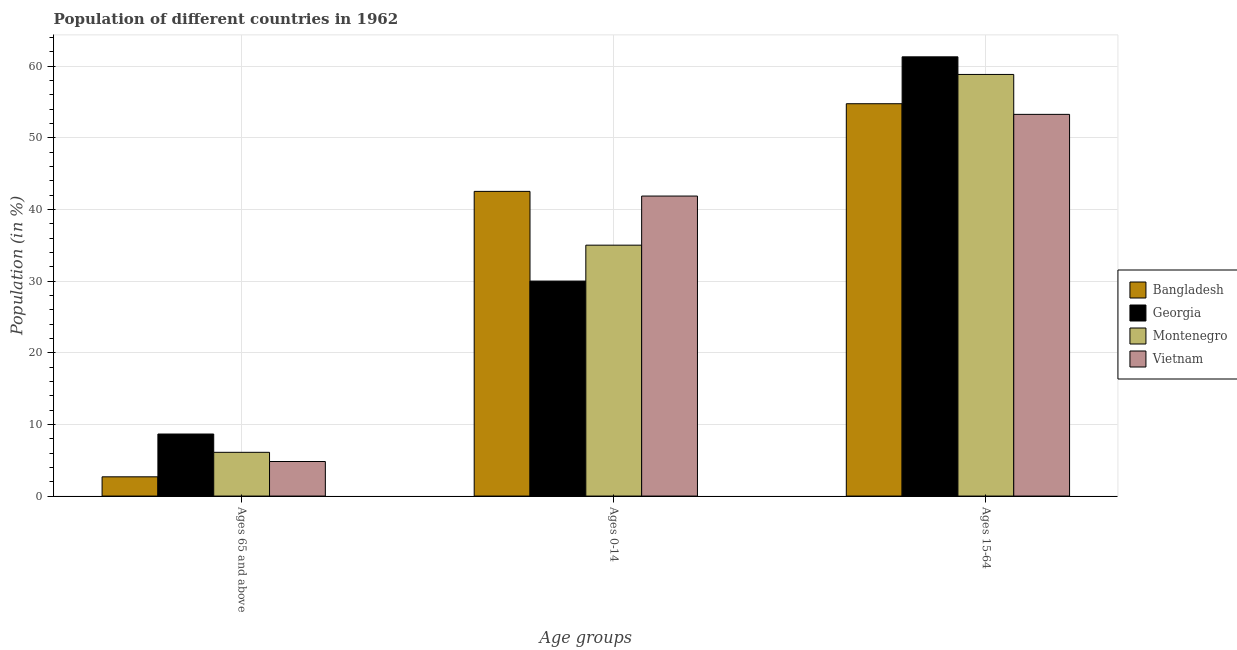How many groups of bars are there?
Give a very brief answer. 3. Are the number of bars per tick equal to the number of legend labels?
Your response must be concise. Yes. How many bars are there on the 2nd tick from the left?
Ensure brevity in your answer.  4. What is the label of the 1st group of bars from the left?
Your answer should be compact. Ages 65 and above. What is the percentage of population within the age-group 0-14 in Vietnam?
Provide a succinct answer. 41.88. Across all countries, what is the maximum percentage of population within the age-group 15-64?
Give a very brief answer. 61.32. Across all countries, what is the minimum percentage of population within the age-group 15-64?
Keep it short and to the point. 53.29. In which country was the percentage of population within the age-group 15-64 maximum?
Make the answer very short. Georgia. In which country was the percentage of population within the age-group 0-14 minimum?
Your answer should be compact. Georgia. What is the total percentage of population within the age-group 0-14 in the graph?
Give a very brief answer. 149.47. What is the difference between the percentage of population within the age-group 0-14 in Georgia and that in Montenegro?
Ensure brevity in your answer.  -5.01. What is the difference between the percentage of population within the age-group 15-64 in Montenegro and the percentage of population within the age-group 0-14 in Bangladesh?
Provide a succinct answer. 16.33. What is the average percentage of population within the age-group of 65 and above per country?
Make the answer very short. 5.57. What is the difference between the percentage of population within the age-group 0-14 and percentage of population within the age-group of 65 and above in Montenegro?
Keep it short and to the point. 28.92. What is the ratio of the percentage of population within the age-group 15-64 in Vietnam to that in Montenegro?
Make the answer very short. 0.91. Is the difference between the percentage of population within the age-group 15-64 in Georgia and Montenegro greater than the difference between the percentage of population within the age-group 0-14 in Georgia and Montenegro?
Your answer should be very brief. Yes. What is the difference between the highest and the second highest percentage of population within the age-group 15-64?
Your answer should be very brief. 2.46. What is the difference between the highest and the lowest percentage of population within the age-group 0-14?
Offer a very short reply. 12.52. Is the sum of the percentage of population within the age-group 0-14 in Montenegro and Georgia greater than the maximum percentage of population within the age-group 15-64 across all countries?
Keep it short and to the point. Yes. What does the 2nd bar from the left in Ages 65 and above represents?
Make the answer very short. Georgia. What does the 2nd bar from the right in Ages 65 and above represents?
Keep it short and to the point. Montenegro. Is it the case that in every country, the sum of the percentage of population within the age-group of 65 and above and percentage of population within the age-group 0-14 is greater than the percentage of population within the age-group 15-64?
Make the answer very short. No. Are all the bars in the graph horizontal?
Offer a terse response. No. How many countries are there in the graph?
Your answer should be very brief. 4. What is the difference between two consecutive major ticks on the Y-axis?
Make the answer very short. 10. Does the graph contain any zero values?
Offer a very short reply. No. Does the graph contain grids?
Keep it short and to the point. Yes. How are the legend labels stacked?
Ensure brevity in your answer.  Vertical. What is the title of the graph?
Give a very brief answer. Population of different countries in 1962. Does "Central African Republic" appear as one of the legend labels in the graph?
Ensure brevity in your answer.  No. What is the label or title of the X-axis?
Offer a terse response. Age groups. What is the Population (in %) of Bangladesh in Ages 65 and above?
Make the answer very short. 2.69. What is the Population (in %) in Georgia in Ages 65 and above?
Ensure brevity in your answer.  8.66. What is the Population (in %) in Montenegro in Ages 65 and above?
Ensure brevity in your answer.  6.11. What is the Population (in %) in Vietnam in Ages 65 and above?
Provide a succinct answer. 4.82. What is the Population (in %) in Bangladesh in Ages 0-14?
Keep it short and to the point. 42.54. What is the Population (in %) of Georgia in Ages 0-14?
Your answer should be compact. 30.02. What is the Population (in %) in Montenegro in Ages 0-14?
Your response must be concise. 35.03. What is the Population (in %) of Vietnam in Ages 0-14?
Your answer should be very brief. 41.88. What is the Population (in %) of Bangladesh in Ages 15-64?
Ensure brevity in your answer.  54.78. What is the Population (in %) in Georgia in Ages 15-64?
Your response must be concise. 61.32. What is the Population (in %) of Montenegro in Ages 15-64?
Offer a terse response. 58.86. What is the Population (in %) in Vietnam in Ages 15-64?
Make the answer very short. 53.29. Across all Age groups, what is the maximum Population (in %) in Bangladesh?
Give a very brief answer. 54.78. Across all Age groups, what is the maximum Population (in %) in Georgia?
Provide a succinct answer. 61.32. Across all Age groups, what is the maximum Population (in %) in Montenegro?
Give a very brief answer. 58.86. Across all Age groups, what is the maximum Population (in %) of Vietnam?
Your response must be concise. 53.29. Across all Age groups, what is the minimum Population (in %) in Bangladesh?
Provide a succinct answer. 2.69. Across all Age groups, what is the minimum Population (in %) in Georgia?
Provide a short and direct response. 8.66. Across all Age groups, what is the minimum Population (in %) of Montenegro?
Keep it short and to the point. 6.11. Across all Age groups, what is the minimum Population (in %) of Vietnam?
Your answer should be very brief. 4.82. What is the total Population (in %) in Bangladesh in the graph?
Provide a succinct answer. 100. What is the total Population (in %) in Georgia in the graph?
Ensure brevity in your answer.  100. What is the total Population (in %) in Vietnam in the graph?
Give a very brief answer. 100. What is the difference between the Population (in %) of Bangladesh in Ages 65 and above and that in Ages 0-14?
Give a very brief answer. -39.85. What is the difference between the Population (in %) in Georgia in Ages 65 and above and that in Ages 0-14?
Provide a succinct answer. -21.35. What is the difference between the Population (in %) of Montenegro in Ages 65 and above and that in Ages 0-14?
Offer a very short reply. -28.92. What is the difference between the Population (in %) of Vietnam in Ages 65 and above and that in Ages 0-14?
Provide a short and direct response. -37.06. What is the difference between the Population (in %) in Bangladesh in Ages 65 and above and that in Ages 15-64?
Offer a terse response. -52.09. What is the difference between the Population (in %) of Georgia in Ages 65 and above and that in Ages 15-64?
Provide a succinct answer. -52.66. What is the difference between the Population (in %) of Montenegro in Ages 65 and above and that in Ages 15-64?
Provide a succinct answer. -52.75. What is the difference between the Population (in %) in Vietnam in Ages 65 and above and that in Ages 15-64?
Keep it short and to the point. -48.47. What is the difference between the Population (in %) in Bangladesh in Ages 0-14 and that in Ages 15-64?
Offer a terse response. -12.24. What is the difference between the Population (in %) of Georgia in Ages 0-14 and that in Ages 15-64?
Your answer should be compact. -31.31. What is the difference between the Population (in %) in Montenegro in Ages 0-14 and that in Ages 15-64?
Your response must be concise. -23.83. What is the difference between the Population (in %) of Vietnam in Ages 0-14 and that in Ages 15-64?
Make the answer very short. -11.41. What is the difference between the Population (in %) of Bangladesh in Ages 65 and above and the Population (in %) of Georgia in Ages 0-14?
Provide a short and direct response. -27.33. What is the difference between the Population (in %) in Bangladesh in Ages 65 and above and the Population (in %) in Montenegro in Ages 0-14?
Your answer should be very brief. -32.34. What is the difference between the Population (in %) of Bangladesh in Ages 65 and above and the Population (in %) of Vietnam in Ages 0-14?
Provide a short and direct response. -39.2. What is the difference between the Population (in %) of Georgia in Ages 65 and above and the Population (in %) of Montenegro in Ages 0-14?
Ensure brevity in your answer.  -26.37. What is the difference between the Population (in %) of Georgia in Ages 65 and above and the Population (in %) of Vietnam in Ages 0-14?
Keep it short and to the point. -33.22. What is the difference between the Population (in %) of Montenegro in Ages 65 and above and the Population (in %) of Vietnam in Ages 0-14?
Offer a terse response. -35.78. What is the difference between the Population (in %) in Bangladesh in Ages 65 and above and the Population (in %) in Georgia in Ages 15-64?
Offer a terse response. -58.63. What is the difference between the Population (in %) of Bangladesh in Ages 65 and above and the Population (in %) of Montenegro in Ages 15-64?
Offer a very short reply. -56.18. What is the difference between the Population (in %) in Bangladesh in Ages 65 and above and the Population (in %) in Vietnam in Ages 15-64?
Keep it short and to the point. -50.6. What is the difference between the Population (in %) of Georgia in Ages 65 and above and the Population (in %) of Montenegro in Ages 15-64?
Make the answer very short. -50.2. What is the difference between the Population (in %) in Georgia in Ages 65 and above and the Population (in %) in Vietnam in Ages 15-64?
Provide a succinct answer. -44.63. What is the difference between the Population (in %) of Montenegro in Ages 65 and above and the Population (in %) of Vietnam in Ages 15-64?
Your response must be concise. -47.18. What is the difference between the Population (in %) of Bangladesh in Ages 0-14 and the Population (in %) of Georgia in Ages 15-64?
Ensure brevity in your answer.  -18.78. What is the difference between the Population (in %) of Bangladesh in Ages 0-14 and the Population (in %) of Montenegro in Ages 15-64?
Your answer should be compact. -16.33. What is the difference between the Population (in %) of Bangladesh in Ages 0-14 and the Population (in %) of Vietnam in Ages 15-64?
Offer a very short reply. -10.75. What is the difference between the Population (in %) of Georgia in Ages 0-14 and the Population (in %) of Montenegro in Ages 15-64?
Offer a very short reply. -28.85. What is the difference between the Population (in %) in Georgia in Ages 0-14 and the Population (in %) in Vietnam in Ages 15-64?
Your response must be concise. -23.27. What is the difference between the Population (in %) in Montenegro in Ages 0-14 and the Population (in %) in Vietnam in Ages 15-64?
Offer a very short reply. -18.26. What is the average Population (in %) in Bangladesh per Age groups?
Make the answer very short. 33.33. What is the average Population (in %) of Georgia per Age groups?
Offer a very short reply. 33.33. What is the average Population (in %) of Montenegro per Age groups?
Offer a terse response. 33.33. What is the average Population (in %) of Vietnam per Age groups?
Offer a terse response. 33.33. What is the difference between the Population (in %) of Bangladesh and Population (in %) of Georgia in Ages 65 and above?
Keep it short and to the point. -5.97. What is the difference between the Population (in %) of Bangladesh and Population (in %) of Montenegro in Ages 65 and above?
Make the answer very short. -3.42. What is the difference between the Population (in %) in Bangladesh and Population (in %) in Vietnam in Ages 65 and above?
Give a very brief answer. -2.14. What is the difference between the Population (in %) in Georgia and Population (in %) in Montenegro in Ages 65 and above?
Your answer should be very brief. 2.55. What is the difference between the Population (in %) of Georgia and Population (in %) of Vietnam in Ages 65 and above?
Your response must be concise. 3.84. What is the difference between the Population (in %) in Montenegro and Population (in %) in Vietnam in Ages 65 and above?
Your answer should be compact. 1.28. What is the difference between the Population (in %) in Bangladesh and Population (in %) in Georgia in Ages 0-14?
Offer a terse response. 12.52. What is the difference between the Population (in %) of Bangladesh and Population (in %) of Montenegro in Ages 0-14?
Make the answer very short. 7.51. What is the difference between the Population (in %) in Bangladesh and Population (in %) in Vietnam in Ages 0-14?
Provide a succinct answer. 0.65. What is the difference between the Population (in %) in Georgia and Population (in %) in Montenegro in Ages 0-14?
Your response must be concise. -5.01. What is the difference between the Population (in %) in Georgia and Population (in %) in Vietnam in Ages 0-14?
Provide a short and direct response. -11.87. What is the difference between the Population (in %) in Montenegro and Population (in %) in Vietnam in Ages 0-14?
Keep it short and to the point. -6.86. What is the difference between the Population (in %) in Bangladesh and Population (in %) in Georgia in Ages 15-64?
Make the answer very short. -6.55. What is the difference between the Population (in %) in Bangladesh and Population (in %) in Montenegro in Ages 15-64?
Ensure brevity in your answer.  -4.09. What is the difference between the Population (in %) of Bangladesh and Population (in %) of Vietnam in Ages 15-64?
Offer a terse response. 1.48. What is the difference between the Population (in %) in Georgia and Population (in %) in Montenegro in Ages 15-64?
Give a very brief answer. 2.46. What is the difference between the Population (in %) in Georgia and Population (in %) in Vietnam in Ages 15-64?
Offer a very short reply. 8.03. What is the difference between the Population (in %) of Montenegro and Population (in %) of Vietnam in Ages 15-64?
Provide a short and direct response. 5.57. What is the ratio of the Population (in %) in Bangladesh in Ages 65 and above to that in Ages 0-14?
Ensure brevity in your answer.  0.06. What is the ratio of the Population (in %) of Georgia in Ages 65 and above to that in Ages 0-14?
Provide a short and direct response. 0.29. What is the ratio of the Population (in %) of Montenegro in Ages 65 and above to that in Ages 0-14?
Give a very brief answer. 0.17. What is the ratio of the Population (in %) in Vietnam in Ages 65 and above to that in Ages 0-14?
Your answer should be very brief. 0.12. What is the ratio of the Population (in %) of Bangladesh in Ages 65 and above to that in Ages 15-64?
Your answer should be very brief. 0.05. What is the ratio of the Population (in %) in Georgia in Ages 65 and above to that in Ages 15-64?
Give a very brief answer. 0.14. What is the ratio of the Population (in %) in Montenegro in Ages 65 and above to that in Ages 15-64?
Give a very brief answer. 0.1. What is the ratio of the Population (in %) of Vietnam in Ages 65 and above to that in Ages 15-64?
Give a very brief answer. 0.09. What is the ratio of the Population (in %) of Bangladesh in Ages 0-14 to that in Ages 15-64?
Your response must be concise. 0.78. What is the ratio of the Population (in %) in Georgia in Ages 0-14 to that in Ages 15-64?
Make the answer very short. 0.49. What is the ratio of the Population (in %) in Montenegro in Ages 0-14 to that in Ages 15-64?
Make the answer very short. 0.6. What is the ratio of the Population (in %) of Vietnam in Ages 0-14 to that in Ages 15-64?
Keep it short and to the point. 0.79. What is the difference between the highest and the second highest Population (in %) of Bangladesh?
Keep it short and to the point. 12.24. What is the difference between the highest and the second highest Population (in %) in Georgia?
Provide a short and direct response. 31.31. What is the difference between the highest and the second highest Population (in %) of Montenegro?
Give a very brief answer. 23.83. What is the difference between the highest and the second highest Population (in %) in Vietnam?
Ensure brevity in your answer.  11.41. What is the difference between the highest and the lowest Population (in %) in Bangladesh?
Give a very brief answer. 52.09. What is the difference between the highest and the lowest Population (in %) in Georgia?
Ensure brevity in your answer.  52.66. What is the difference between the highest and the lowest Population (in %) of Montenegro?
Your response must be concise. 52.75. What is the difference between the highest and the lowest Population (in %) in Vietnam?
Offer a very short reply. 48.47. 